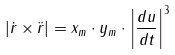<formula> <loc_0><loc_0><loc_500><loc_500>\left | \dot { r } \times \ddot { r } \right | = x _ { m } \cdot y _ { m } \cdot \left | \frac { d u } { d t } \right | ^ { 3 }</formula> 